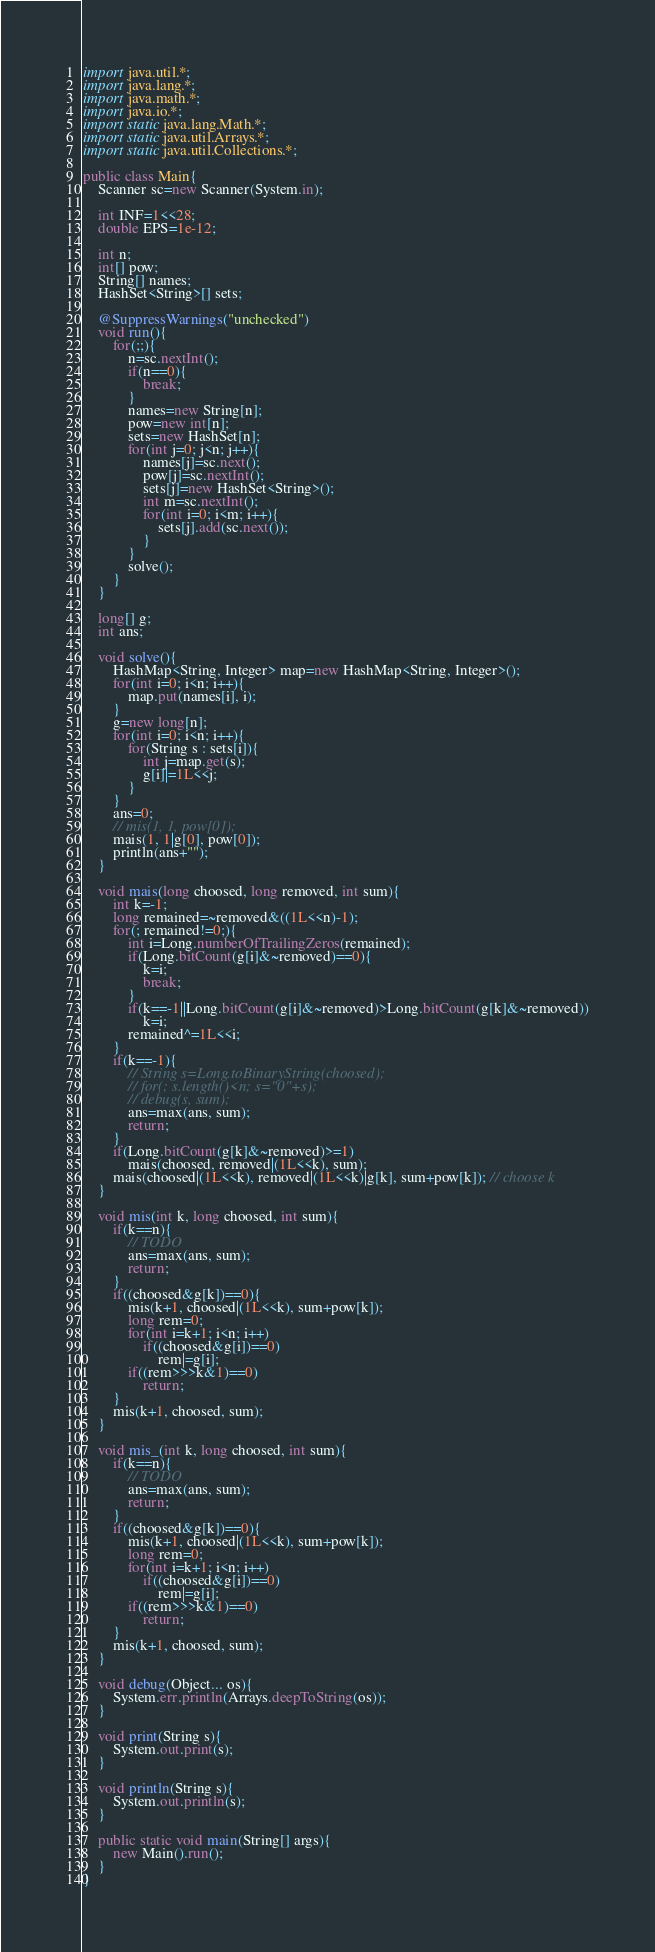<code> <loc_0><loc_0><loc_500><loc_500><_Java_>import java.util.*;
import java.lang.*;
import java.math.*;
import java.io.*;
import static java.lang.Math.*;
import static java.util.Arrays.*;
import static java.util.Collections.*;

public class Main{
	Scanner sc=new Scanner(System.in);

	int INF=1<<28;
	double EPS=1e-12;

	int n;
	int[] pow;
	String[] names;
	HashSet<String>[] sets;

	@SuppressWarnings("unchecked")
	void run(){
		for(;;){
			n=sc.nextInt();
			if(n==0){
				break;
			}
			names=new String[n];
			pow=new int[n];
			sets=new HashSet[n];
			for(int j=0; j<n; j++){
				names[j]=sc.next();
				pow[j]=sc.nextInt();
				sets[j]=new HashSet<String>();
				int m=sc.nextInt();
				for(int i=0; i<m; i++){
					sets[j].add(sc.next());
				}
			}
			solve();
		}
	}

	long[] g;
	int ans;

	void solve(){
		HashMap<String, Integer> map=new HashMap<String, Integer>();
		for(int i=0; i<n; i++){
			map.put(names[i], i);
		}
		g=new long[n];
		for(int i=0; i<n; i++){
			for(String s : sets[i]){
				int j=map.get(s);
				g[i]|=1L<<j;
			}
		}
		ans=0;
		// mis(1, 1, pow[0]);
		mais(1, 1|g[0], pow[0]);
		println(ans+"");
	}

	void mais(long choosed, long removed, int sum){
		int k=-1;
		long remained=~removed&((1L<<n)-1);
		for(; remained!=0;){
			int i=Long.numberOfTrailingZeros(remained);
			if(Long.bitCount(g[i]&~removed)==0){
				k=i;
				break;
			}
			if(k==-1||Long.bitCount(g[i]&~removed)>Long.bitCount(g[k]&~removed))
				k=i;
			remained^=1L<<i;
		}
		if(k==-1){
			// String s=Long.toBinaryString(choosed);
			// for(; s.length()<n; s="0"+s);
			// debug(s, sum);
			ans=max(ans, sum);
			return;
		}
		if(Long.bitCount(g[k]&~removed)>=1)
			mais(choosed, removed|(1L<<k), sum);
		mais(choosed|(1L<<k), removed|(1L<<k)|g[k], sum+pow[k]); // choose k
	}

	void mis(int k, long choosed, int sum){
		if(k==n){
			// TODO
			ans=max(ans, sum);
			return;
		}
		if((choosed&g[k])==0){
			mis(k+1, choosed|(1L<<k), sum+pow[k]);
			long rem=0;
			for(int i=k+1; i<n; i++)
				if((choosed&g[i])==0)
					rem|=g[i];
			if((rem>>>k&1)==0)
				return;
		}
		mis(k+1, choosed, sum);
	}

	void mis_(int k, long choosed, int sum){
		if(k==n){
			// TODO
			ans=max(ans, sum);
			return;
		}
		if((choosed&g[k])==0){
			mis(k+1, choosed|(1L<<k), sum+pow[k]);
			long rem=0;
			for(int i=k+1; i<n; i++)
				if((choosed&g[i])==0)
					rem|=g[i];
			if((rem>>>k&1)==0)
				return;
		}
		mis(k+1, choosed, sum);
	}

	void debug(Object... os){
		System.err.println(Arrays.deepToString(os));
	}

	void print(String s){
		System.out.print(s);
	}

	void println(String s){
		System.out.println(s);
	}

	public static void main(String[] args){
		new Main().run();
	}
}</code> 